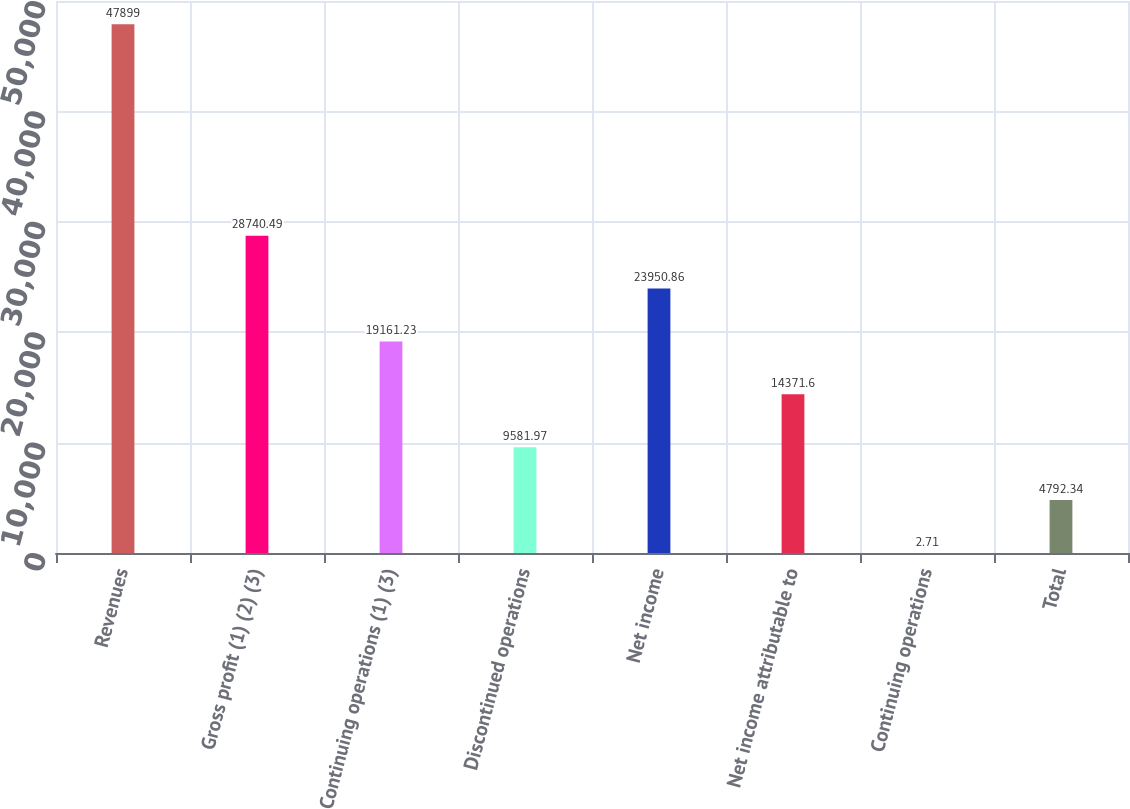Convert chart to OTSL. <chart><loc_0><loc_0><loc_500><loc_500><bar_chart><fcel>Revenues<fcel>Gross profit (1) (2) (3)<fcel>Continuing operations (1) (3)<fcel>Discontinued operations<fcel>Net income<fcel>Net income attributable to<fcel>Continuing operations<fcel>Total<nl><fcel>47899<fcel>28740.5<fcel>19161.2<fcel>9581.97<fcel>23950.9<fcel>14371.6<fcel>2.71<fcel>4792.34<nl></chart> 